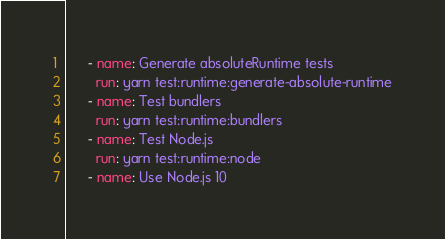<code> <loc_0><loc_0><loc_500><loc_500><_YAML_>      - name: Generate absoluteRuntime tests
        run: yarn test:runtime:generate-absolute-runtime
      - name: Test bundlers
        run: yarn test:runtime:bundlers
      - name: Test Node.js
        run: yarn test:runtime:node
      - name: Use Node.js 10</code> 